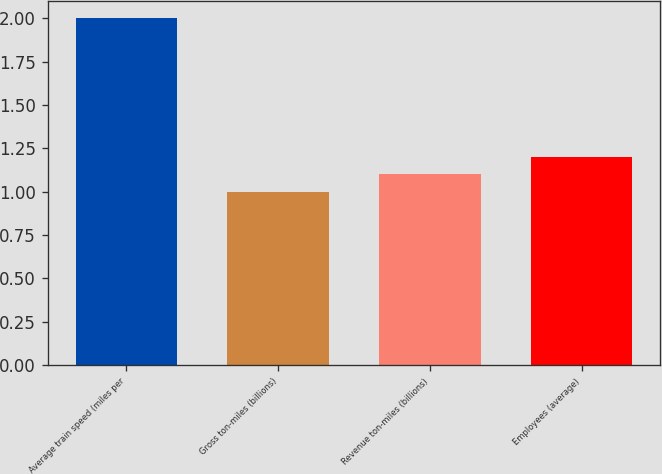Convert chart. <chart><loc_0><loc_0><loc_500><loc_500><bar_chart><fcel>Average train speed (miles per<fcel>Gross ton-miles (billions)<fcel>Revenue ton-miles (billions)<fcel>Employees (average)<nl><fcel>2<fcel>1<fcel>1.1<fcel>1.2<nl></chart> 